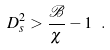Convert formula to latex. <formula><loc_0><loc_0><loc_500><loc_500>D _ { s } ^ { 2 } > \frac { \mathcal { B } } { \chi } - 1 \ .</formula> 